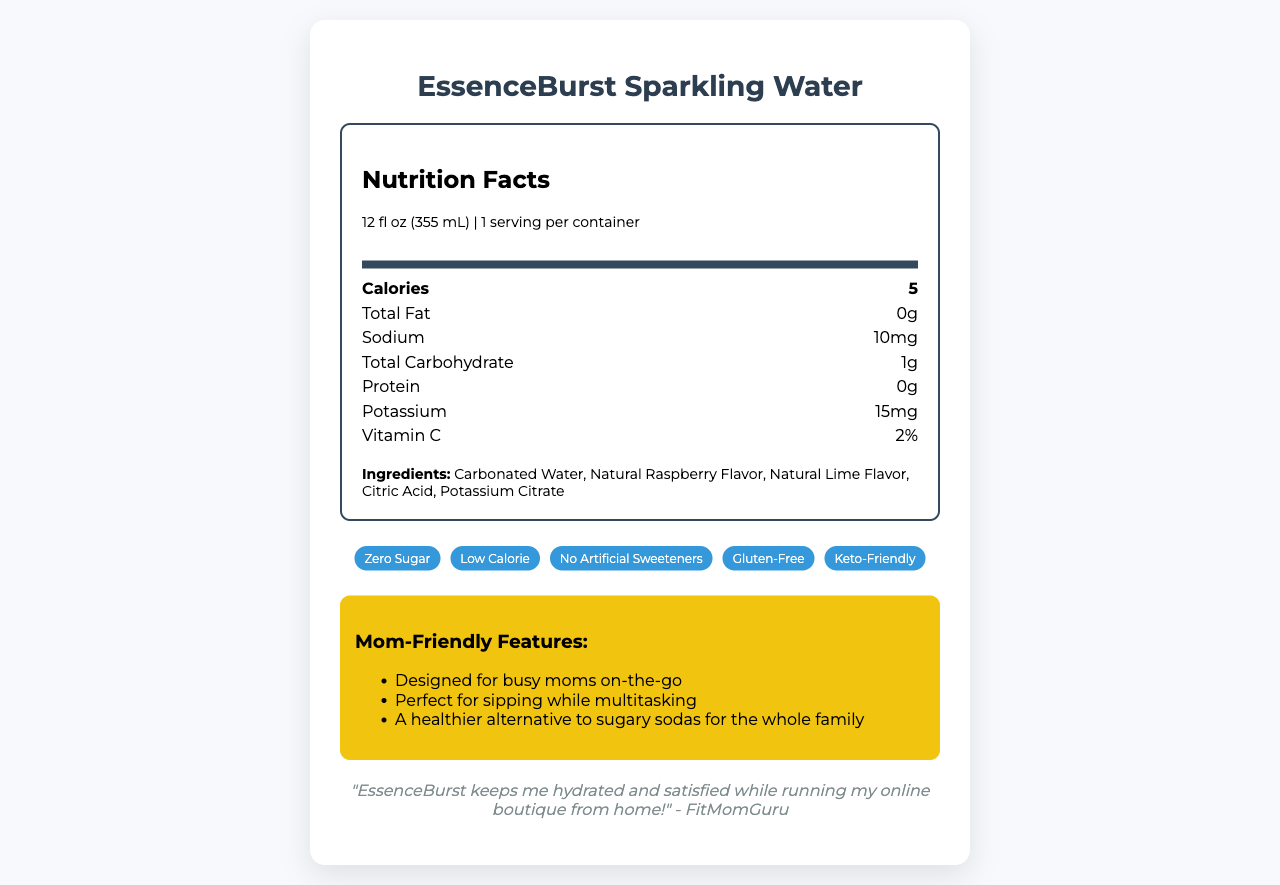what is the serving size of EssenceBurst Sparkling Water? The serving size is mentioned at the beginning of the Nutrition Facts section.
Answer: 12 fl oz (355 mL) How many calories are in one serving of EssenceBurst Sparkling Water? The calories per serving are listed under the "Calories" section.
Answer: 5 Which flavors are included in the natural fruit essences? The ingredients list mentions "Natural Raspberry Flavor" and "Natural Lime Flavor."
Answer: Raspberry and Lime What is the sodium content of EssenceBurst Sparkling Water? Sodium content is listed in the Nutrition Facts section.
Answer: 10 mg How much total carbohydrate does one serving of EssenceBurst Sparkling Water contain? The total carbohydrate content is listed in the Nutrition Facts section.
Answer: 1g Is EssenceBurst Sparkling Water considered keto-friendly? One of the marketing claims is "Keto-Friendly."
Answer: Yes Who endorses EssenceBurst Sparkling Water? The influencer connection section mentions that the product is endorsed by FitMomGuru.
Answer: FitMomGuru Where is EssenceBurst Sparkling Water sourced from? The additional info section mentions it is made with purified water from natural springs in the Rocky Mountains.
Answer: Natural springs in the Rocky Mountains For how long is EssenceBurst Sparkling Water shelf-stable? The additional info section lists the shelf life.
Answer: 18 months from date of production Are there any sugars in EssenceBurst Sparkling Water? The Nutrition Facts states that total sugars and added sugars are both 0g.
Answer: No What is the percentage of Vitamin C in EssenceBurst Sparkling Water? The Nutrition Facts section lists Vitamin C as 2%.
Answer: 2% Does EssenceBurst Sparkling Water contain any allergenic ingredients? The allergen info section mentions that it is produced in a facility that processes nuts and soy.
Answer: Produced in a facility that processes nuts and soy What are the mom-friendly features of EssenceBurst Sparkling Water for busy moms on-the-go? The mom-friendly features section mentions these three features specifically.
Answer: Easy-open tab, Spill-proof design, Kid-approved taste Select the correct statement about EssenceBurst Sparkling Water: I. It contains artificial sweeteners II. It is gluten-free III. It is high in calories IV. It is only suitable for adults The marketing claims state that it is "Gluten-Free," while it also mentions "No Artificial Sweeteners" and "Kid-Approved Taste."
Answer: II Which of the following ingredients is not included in EssenceBurst Sparkling Water? A. Potassium Citrate B. Citric Acid C. Artificial Raspberry Flavor D. Carbonated Water The ingredients list includes Potassium Citrate, Citric Acid, and Carbonated Water, but not Artificial Raspberry Flavor.
Answer: C Does EssenceBurst Sparkling Water contain any protein? The Nutrition Facts section lists 0g of protein.
Answer: No Summarize the main idea of the document. The document provides detailed nutritional information, marketing claims, mom-friendly features, and an endorsement by an influencer catering to health-conscious consumers, particularly busy moms.
Answer: EssenceBurst Sparkling Water is a low-calorie, naturally flavored sparkling water endorsed by FitMomGuru. It is keto-friendly, gluten-free, and appealing to both busy moms and children, offering practical benefits like an easy-open tab and spill-proof design. What flavors do EssenceBurst Sparkling Water offer besides raspberry and lime? The document only lists raspberry and lime as the natural flavors included; it doesn't mention any other flavors.
Answer: Cannot be determined 